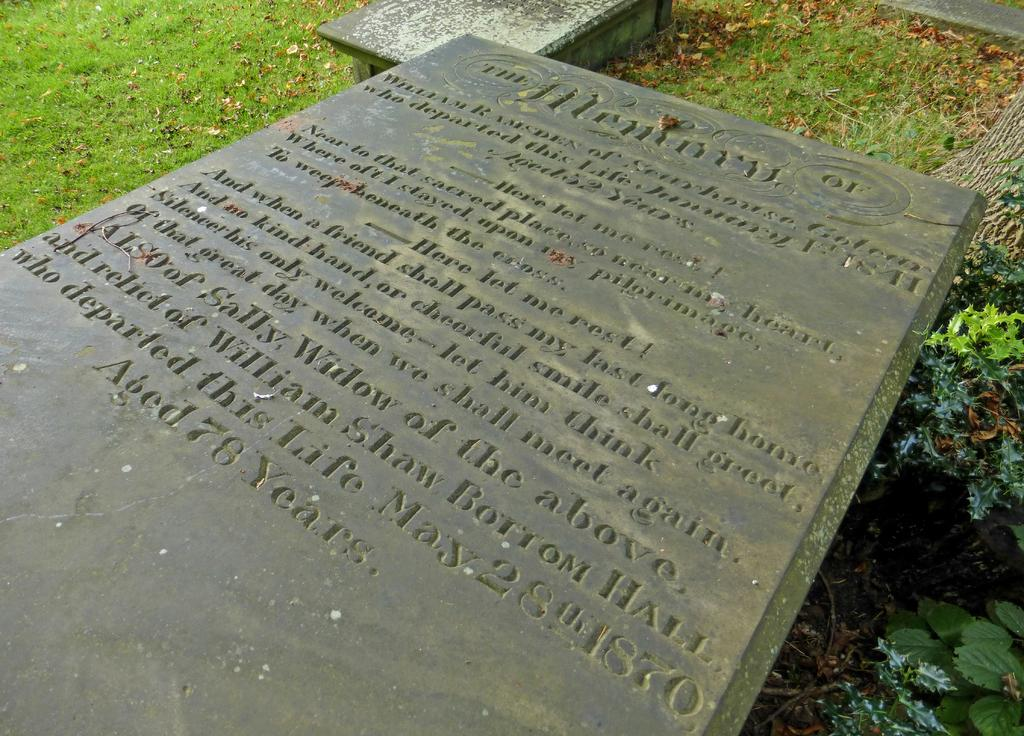What is written on in the image? There are texts written on a stone plate in the image. What can be seen in the background of the image? There are leaves on the grass in the background. What is present on the right side of the image? There are plants on the right side of the image. What is the main structure in the image? There is a platform in the image. How many apples are hanging from the plants in the image? There are no apples present in the image; only plants are visible. What type of shade is provided by the platform in the image? The platform in the image does not provide any shade, as it is not mentioned to have a roof or covering. 